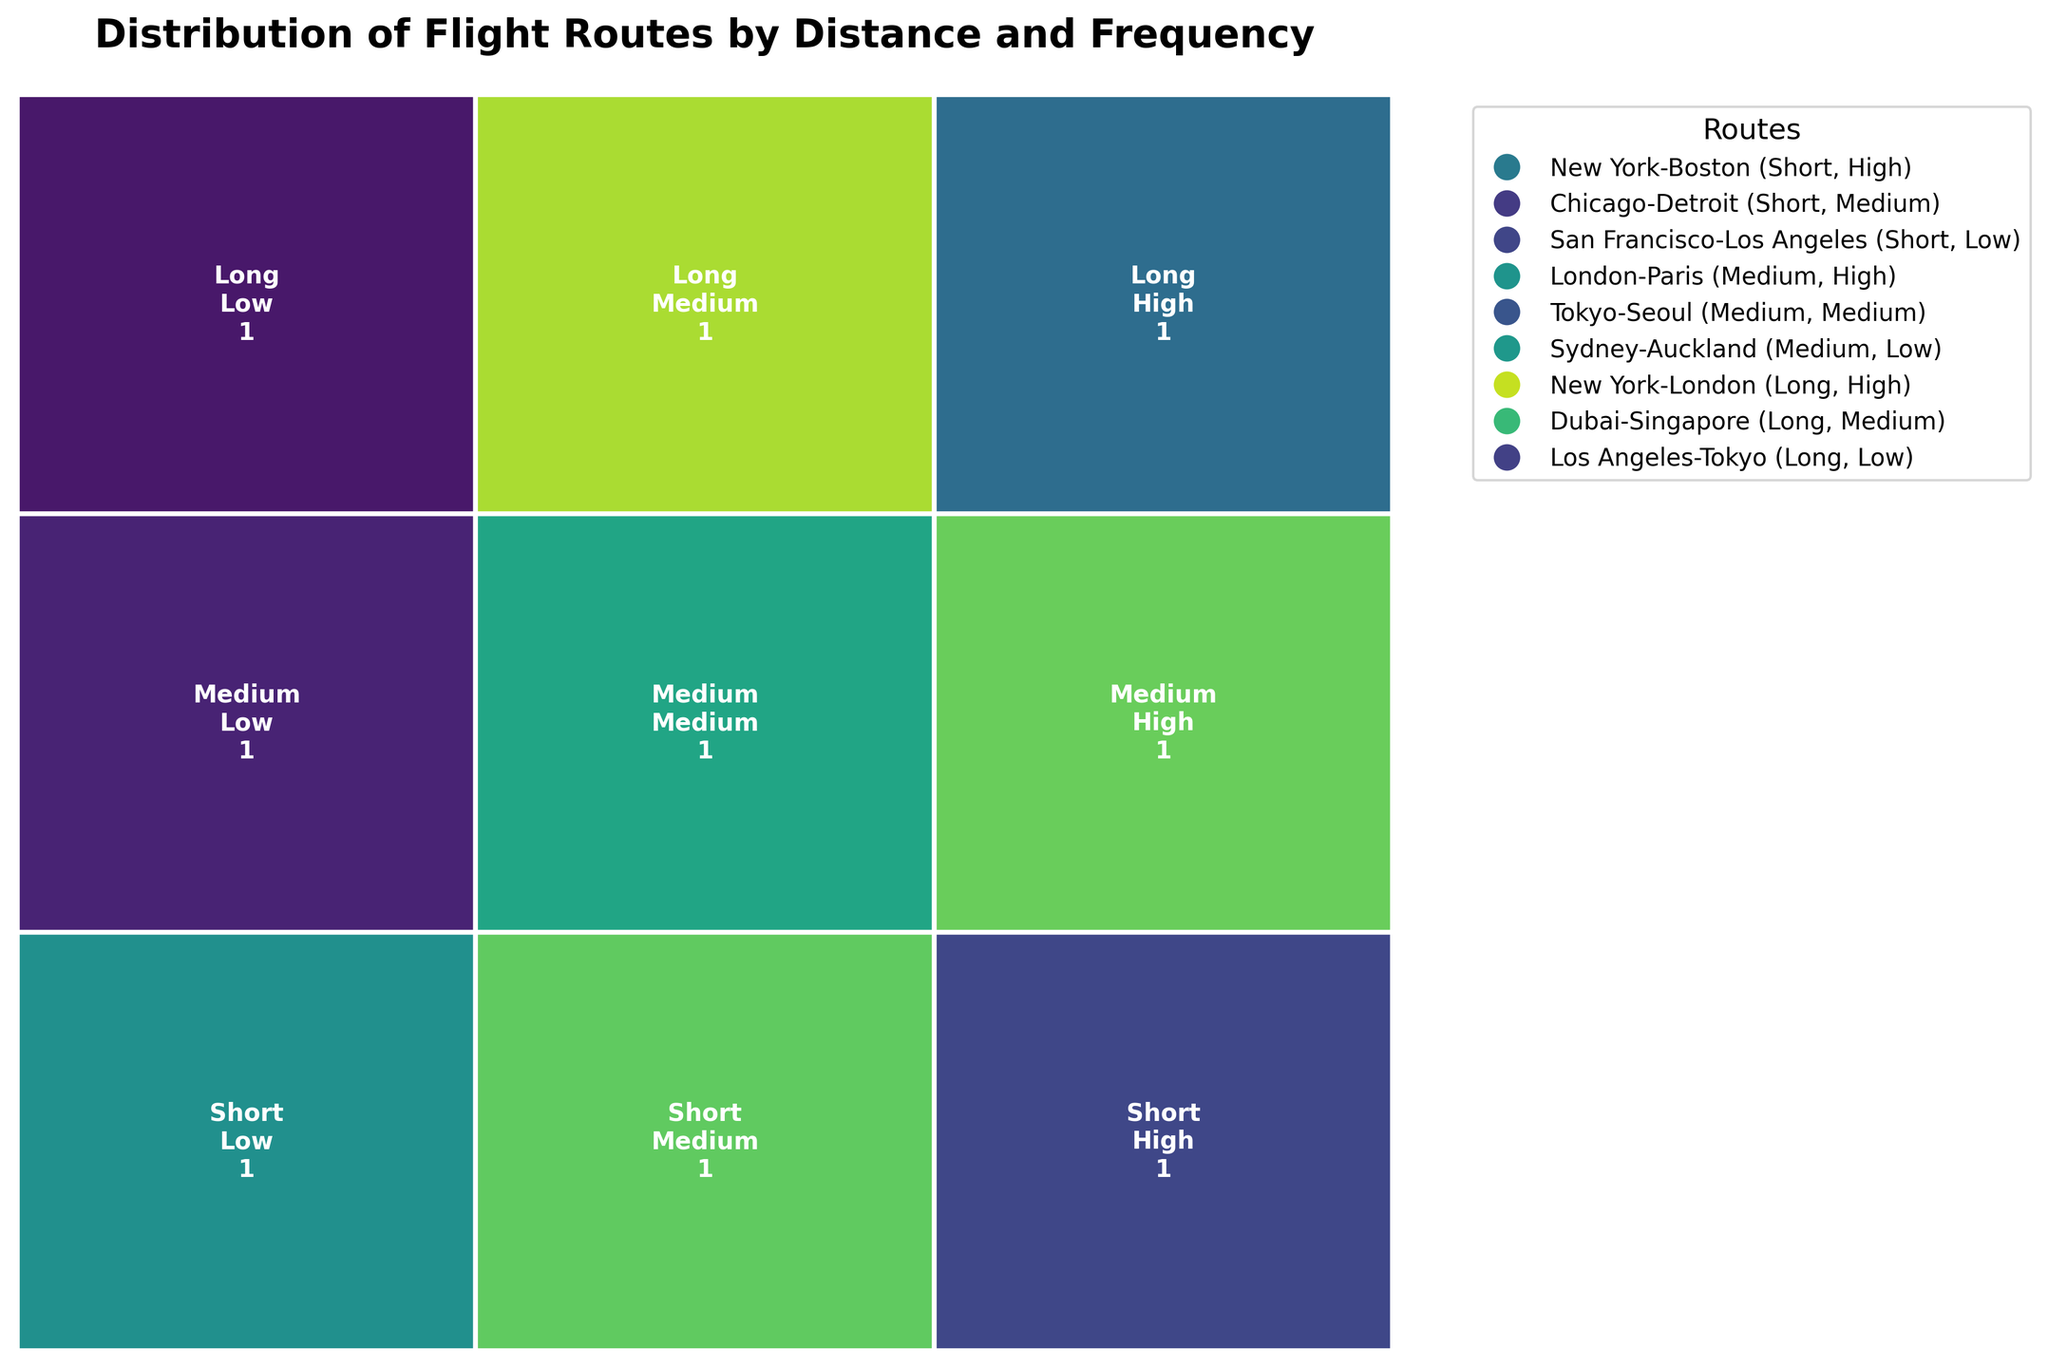What is the title of the plot? The title is usually displayed at the top of the figure. In this case, the title is "Distribution of Flight Routes by Distance and Frequency".
Answer: Distribution of Flight Routes by Distance and Frequency How many flight routes are categorized under short distances with high frequency? By looking at the figures within the mosaic plot rectangles, the number under 'Short' distances and 'High' frequency is clearly shown.
Answer: 1 Which distance category has the most flight routes in total? To answer this, identify the largest aggregated height for a distance category on the y-axis. The sum of the values for each distance category shows that 'Medium' has the most routes.
Answer: Medium Which frequency of service is most common among long-distance routes? By examining the divisions of the 'Long' distance section in the plot, "High" frequency rectangles represent the greatest area in this section.
Answer: High What is the total number of flight routes shown in the mosaic plot? Each cell in the mosaic plot indicates the number of routes for each distance-frequency combination. Adding these values together (1 + 1 + 1 + 1 + 1 + 1 + 1 + 1 + 1) gives the total number.
Answer: 9 Which route is represented by short distance and low frequency? The label inside the rectangle for 'Short' distances and 'Low' frequency provides the route information.
Answer: San Francisco-Los Angeles Are there more medium distance routes with medium frequency or long-distance routes with medium frequency? Compare the cell values for 'Medium' distances with 'Medium' frequency and 'Long' distances with 'Medium' frequency. Both display a count of 1.
Answer: Equal What is the most frequent route service pattern? Identify the largest rectangle within the entire plot, which corresponds to the most common combination of distance and frequency of service. Here, 'Medium' distance and 'Medium' frequency appears most frequently.
Answer: Medium, Medium Compare the number of flight routes between New York-Boston and Los Angeles-Tokyo. From the mosaic plot, find and compare the counts of the routes "New York-Boston" under 'Short' distance and 'High' frequency, and "Los Angeles-Tokyo" under 'Long' distance and 'Low' frequency. Each has a count of 1.
Answer: Equal Which frequency of service appears least for medium distances? Within the 'Medium' distance section, the smallest rectangle indicates the least frequency. Here, 'Low' frequency holds this position.
Answer: Low 